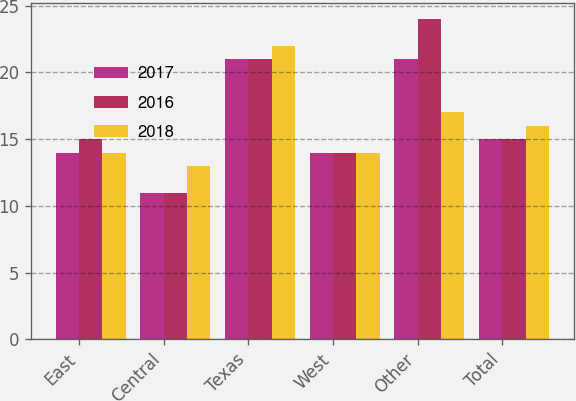<chart> <loc_0><loc_0><loc_500><loc_500><stacked_bar_chart><ecel><fcel>East<fcel>Central<fcel>Texas<fcel>West<fcel>Other<fcel>Total<nl><fcel>2017<fcel>14<fcel>11<fcel>21<fcel>14<fcel>21<fcel>15<nl><fcel>2016<fcel>15<fcel>11<fcel>21<fcel>14<fcel>24<fcel>15<nl><fcel>2018<fcel>14<fcel>13<fcel>22<fcel>14<fcel>17<fcel>16<nl></chart> 